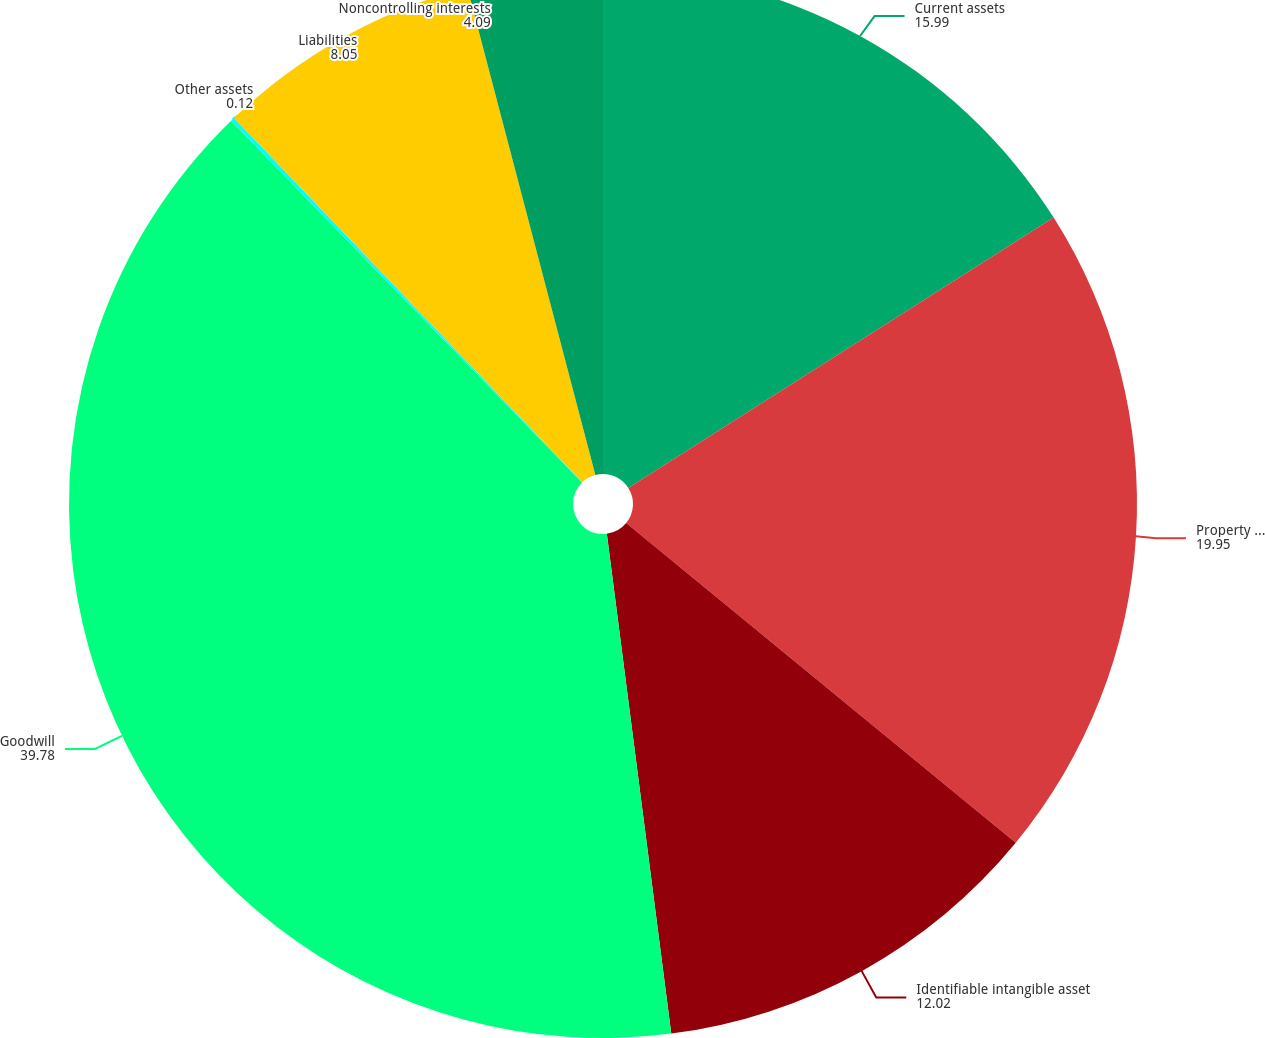Convert chart to OTSL. <chart><loc_0><loc_0><loc_500><loc_500><pie_chart><fcel>Current assets<fcel>Property and equipment<fcel>Identifiable intangible asset<fcel>Goodwill<fcel>Other assets<fcel>Liabilities<fcel>Noncontrolling interests<nl><fcel>15.99%<fcel>19.95%<fcel>12.02%<fcel>39.78%<fcel>0.12%<fcel>8.05%<fcel>4.09%<nl></chart> 